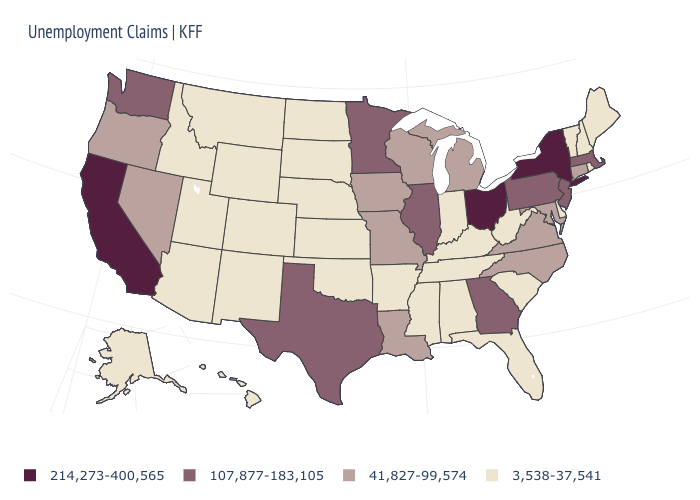What is the value of Maine?
Be succinct. 3,538-37,541. What is the value of South Carolina?
Answer briefly. 3,538-37,541. What is the highest value in the USA?
Short answer required. 214,273-400,565. Does the first symbol in the legend represent the smallest category?
Be succinct. No. Name the states that have a value in the range 3,538-37,541?
Write a very short answer. Alabama, Alaska, Arizona, Arkansas, Colorado, Delaware, Florida, Hawaii, Idaho, Indiana, Kansas, Kentucky, Maine, Mississippi, Montana, Nebraska, New Hampshire, New Mexico, North Dakota, Oklahoma, Rhode Island, South Carolina, South Dakota, Tennessee, Utah, Vermont, West Virginia, Wyoming. Does North Dakota have the same value as Iowa?
Be succinct. No. Which states have the lowest value in the USA?
Short answer required. Alabama, Alaska, Arizona, Arkansas, Colorado, Delaware, Florida, Hawaii, Idaho, Indiana, Kansas, Kentucky, Maine, Mississippi, Montana, Nebraska, New Hampshire, New Mexico, North Dakota, Oklahoma, Rhode Island, South Carolina, South Dakota, Tennessee, Utah, Vermont, West Virginia, Wyoming. What is the value of New Jersey?
Answer briefly. 107,877-183,105. Does the map have missing data?
Be succinct. No. Does New Hampshire have the lowest value in the Northeast?
Concise answer only. Yes. What is the value of South Dakota?
Be succinct. 3,538-37,541. What is the highest value in states that border Louisiana?
Quick response, please. 107,877-183,105. Name the states that have a value in the range 107,877-183,105?
Short answer required. Georgia, Illinois, Massachusetts, Minnesota, New Jersey, Pennsylvania, Texas, Washington. Which states have the lowest value in the West?
Give a very brief answer. Alaska, Arizona, Colorado, Hawaii, Idaho, Montana, New Mexico, Utah, Wyoming. Name the states that have a value in the range 107,877-183,105?
Give a very brief answer. Georgia, Illinois, Massachusetts, Minnesota, New Jersey, Pennsylvania, Texas, Washington. 